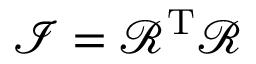Convert formula to latex. <formula><loc_0><loc_0><loc_500><loc_500>{ \mathcal { I } } = { \mathcal { R } } ^ { T } { \mathcal { R } }</formula> 